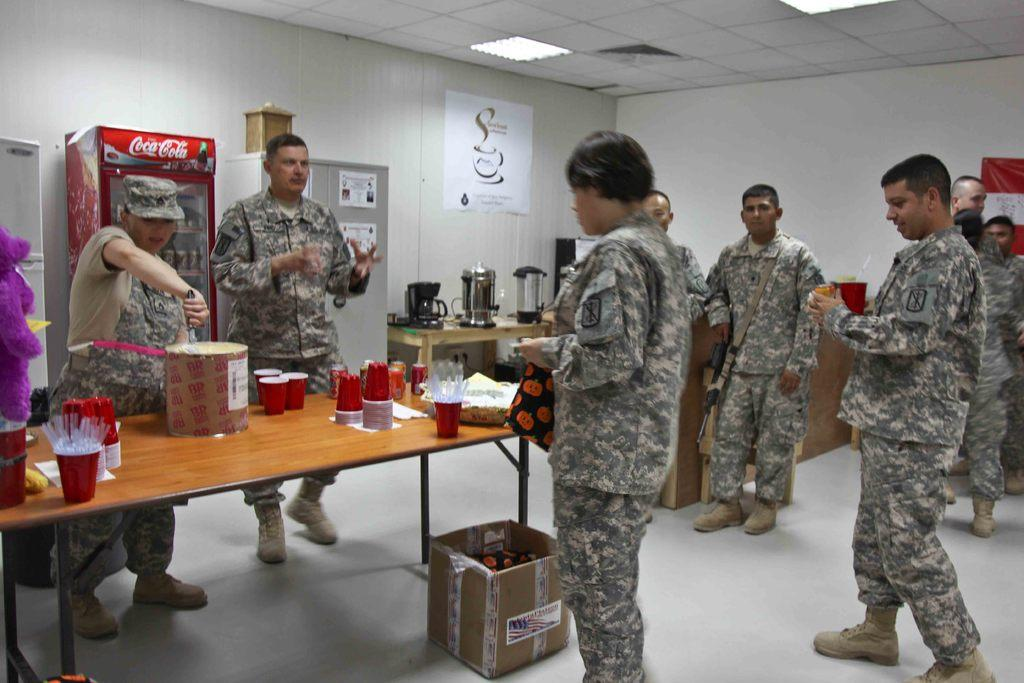How many people are in the image? There is a group of persons in the image. What are the people wearing? The persons are wearing similar dress. What can be seen on the table in the image? There are glasses on the table. What is the main object in the middle of the image? There is an object in the middle of the image. What trail can be seen in the image? There is no trail present in the image. What type of wash is being used by the persons in the image? There is no information about any wash being used by the persons in the image. 